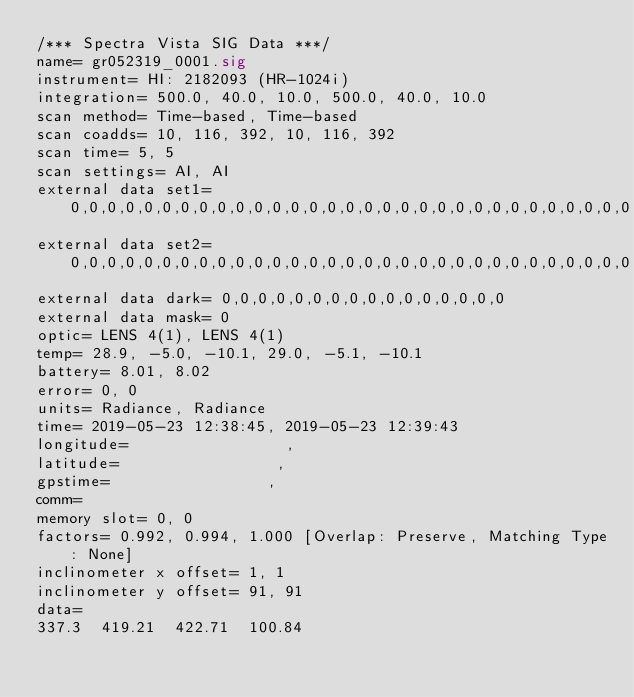Convert code to text. <code><loc_0><loc_0><loc_500><loc_500><_SML_>/*** Spectra Vista SIG Data ***/
name= gr052319_0001.sig
instrument= HI: 2182093 (HR-1024i)
integration= 500.0, 40.0, 10.0, 500.0, 40.0, 10.0
scan method= Time-based, Time-based
scan coadds= 10, 116, 392, 10, 116, 392
scan time= 5, 5
scan settings= AI, AI
external data set1= 0,0,0,0,0,0,0,0,0,0,0,0,0,0,0,0,0,0,0,0,0,0,0,0,0,0,0,0,0,0,0,0
external data set2= 0,0,0,0,0,0,0,0,0,0,0,0,0,0,0,0,0,0,0,0,0,0,0,0,0,0,0,0,0,0,0,0
external data dark= 0,0,0,0,0,0,0,0,0,0,0,0,0,0,0,0
external data mask= 0
optic= LENS 4(1), LENS 4(1)
temp= 28.9, -5.0, -10.1, 29.0, -5.1, -10.1
battery= 8.01, 8.02
error= 0, 0
units= Radiance, Radiance
time= 2019-05-23 12:38:45, 2019-05-23 12:39:43
longitude=                 ,                 
latitude=                 ,                 
gpstime=                 ,                 
comm= 
memory slot= 0, 0
factors= 0.992, 0.994, 1.000 [Overlap: Preserve, Matching Type: None]
inclinometer x offset= 1, 1
inclinometer y offset= 91, 91
data= 
337.3  419.21  422.71  100.84</code> 